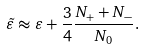<formula> <loc_0><loc_0><loc_500><loc_500>\tilde { \varepsilon } \approx \varepsilon + \frac { 3 } { 4 } \frac { N _ { + } + N _ { - } } { N _ { 0 } } .</formula> 